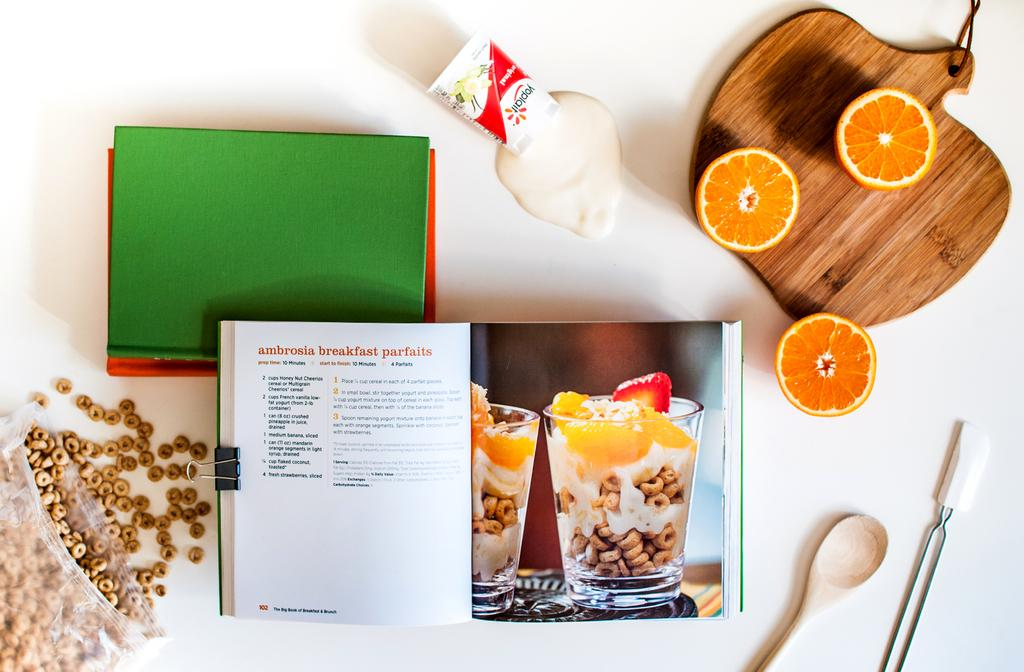What is the main object in the image? There is a wooden board in the image. What is placed on the wooden board? There is a spoon and a fruit on the wooden board. What else can be seen in the image besides the wooden board? There are papers, a book, seeds in a cover, and a milk pack in the image. How does the beef look like on the wooden board? There is no beef present in the image. Is the wooden board placed on a slope in the image? The wooden board is not placed on a slope in the image; it appears to be on a flat surface. 